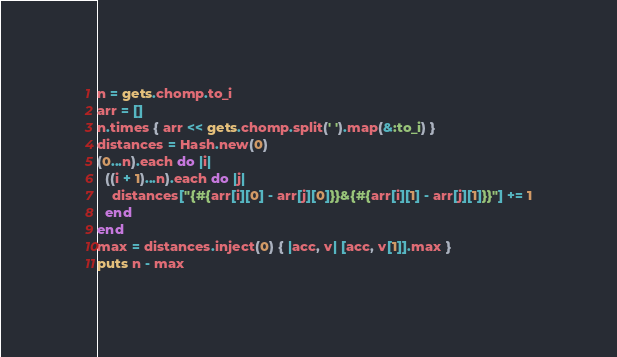<code> <loc_0><loc_0><loc_500><loc_500><_Ruby_>n = gets.chomp.to_i
arr = []
n.times { arr << gets.chomp.split(' ').map(&:to_i) }
distances = Hash.new(0)
(0...n).each do |i|
  ((i + 1)...n).each do |j|
    distances["{#{arr[i][0] - arr[j][0]}}&{#{arr[i][1] - arr[j][1]}}"] += 1
  end
end
max = distances.inject(0) { |acc, v| [acc, v[1]].max }
puts n - max</code> 